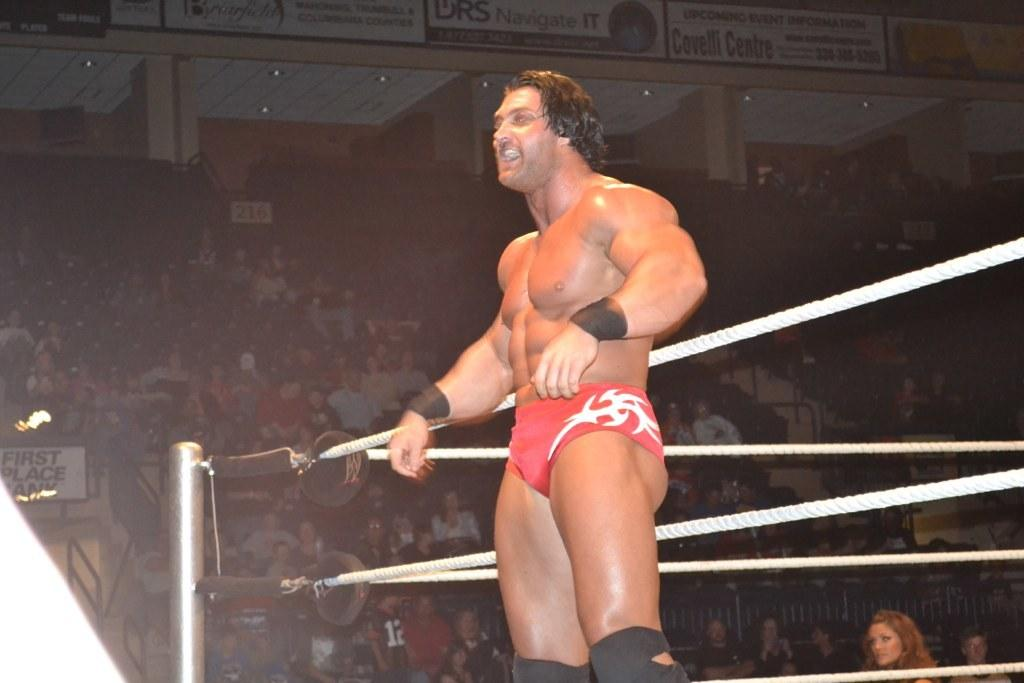<image>
Offer a succinct explanation of the picture presented. A muscular man stands out side of a boxing ring at a packed event put on by First Place Bank. 